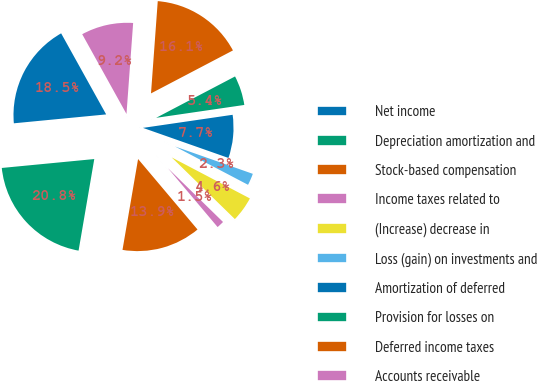Convert chart to OTSL. <chart><loc_0><loc_0><loc_500><loc_500><pie_chart><fcel>Net income<fcel>Depreciation amortization and<fcel>Stock-based compensation<fcel>Income taxes related to<fcel>(Increase) decrease in<fcel>Loss (gain) on investments and<fcel>Amortization of deferred<fcel>Provision for losses on<fcel>Deferred income taxes<fcel>Accounts receivable<nl><fcel>18.46%<fcel>20.77%<fcel>13.85%<fcel>1.54%<fcel>4.62%<fcel>2.31%<fcel>7.69%<fcel>5.38%<fcel>16.15%<fcel>9.23%<nl></chart> 